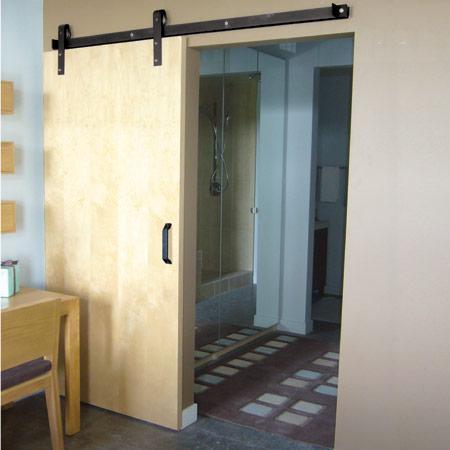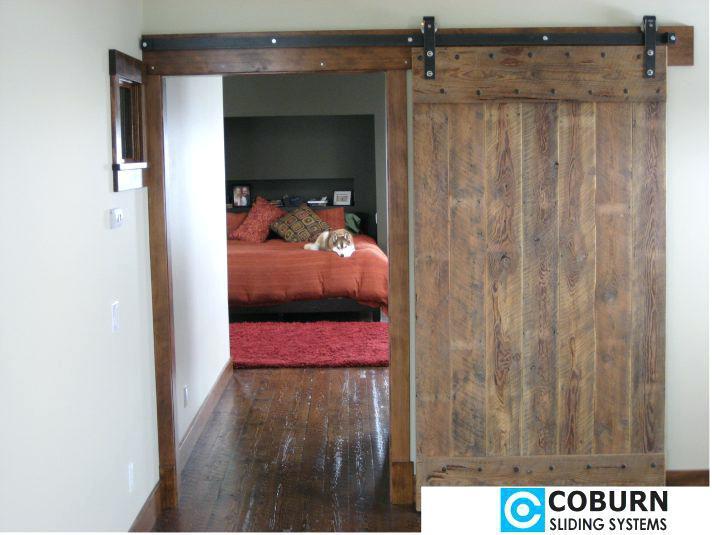The first image is the image on the left, the second image is the image on the right. Analyze the images presented: Is the assertion "There are three sliding doors." valid? Answer yes or no. No. 